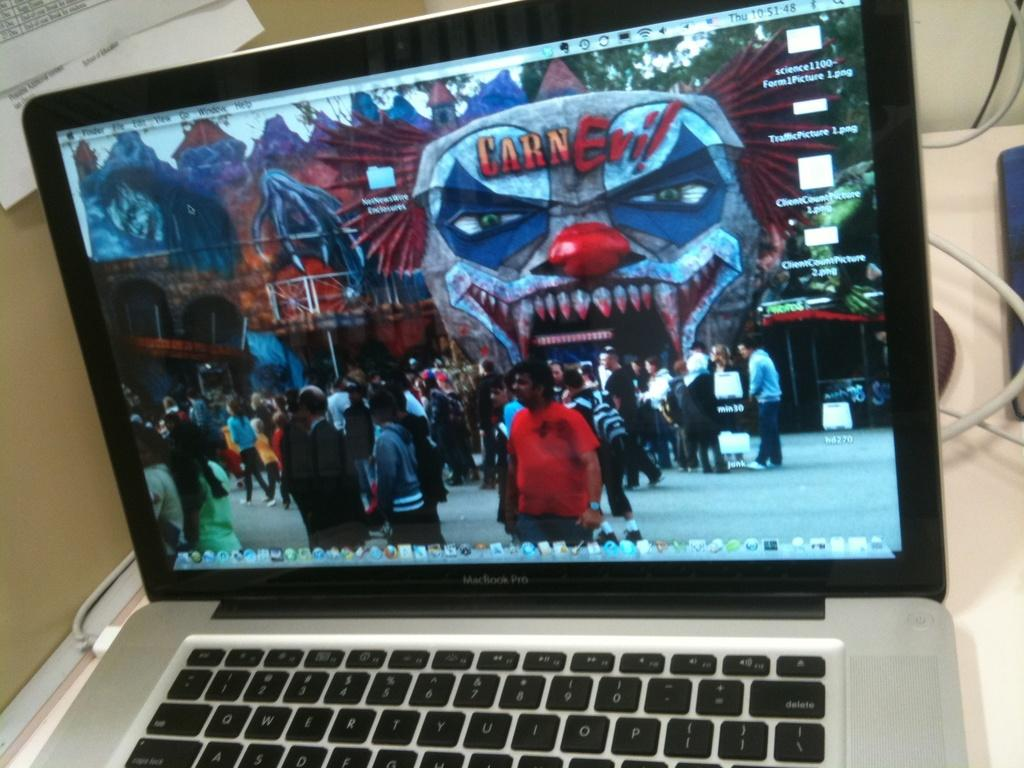<image>
Offer a succinct explanation of the picture presented. Mac Book Pro computer with a wallpaper showing a Carn Evil festival. 